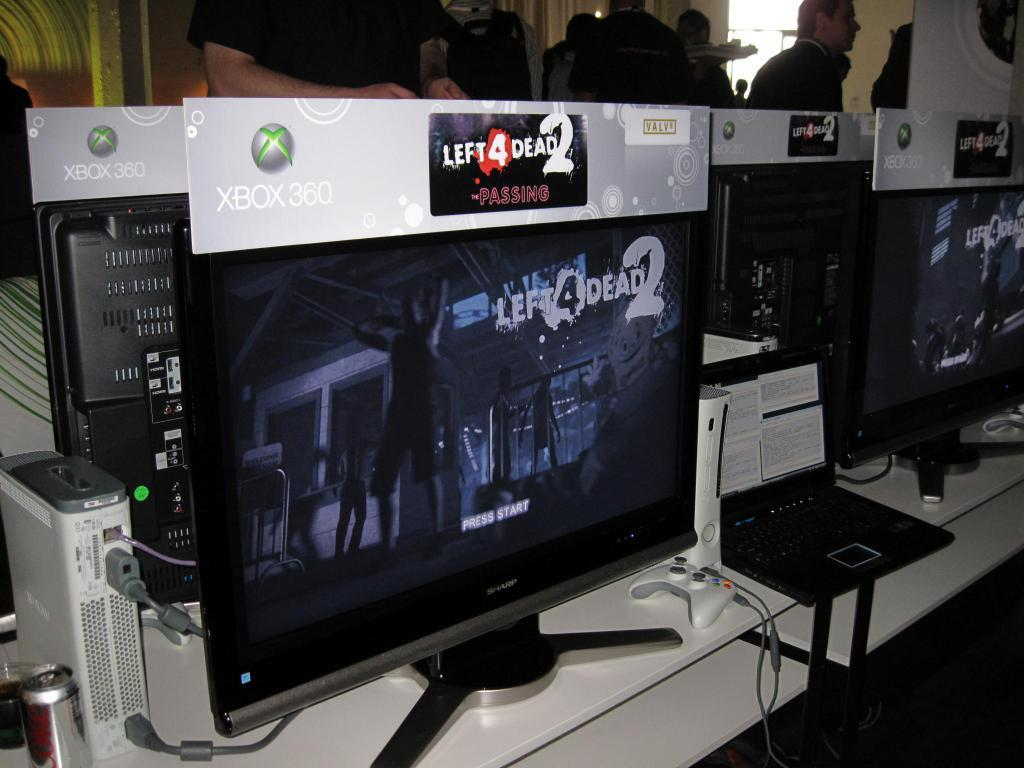<image>
Write a terse but informative summary of the picture. A monitor advertises the Xbox 360 game Left 4 Dead 2. 